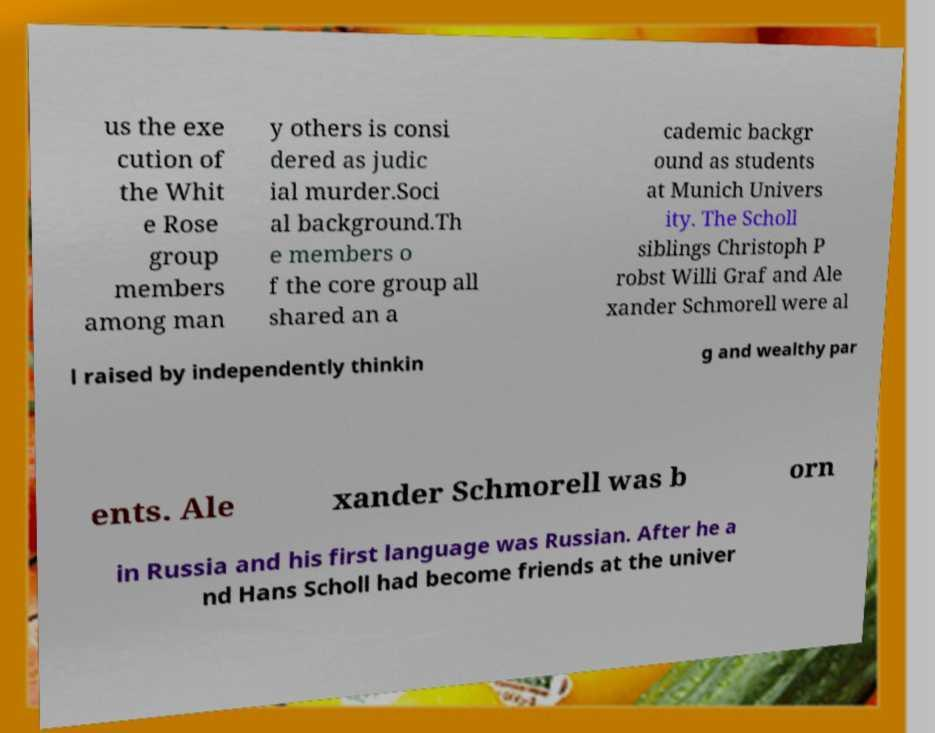Can you accurately transcribe the text from the provided image for me? us the exe cution of the Whit e Rose group members among man y others is consi dered as judic ial murder.Soci al background.Th e members o f the core group all shared an a cademic backgr ound as students at Munich Univers ity. The Scholl siblings Christoph P robst Willi Graf and Ale xander Schmorell were al l raised by independently thinkin g and wealthy par ents. Ale xander Schmorell was b orn in Russia and his first language was Russian. After he a nd Hans Scholl had become friends at the univer 